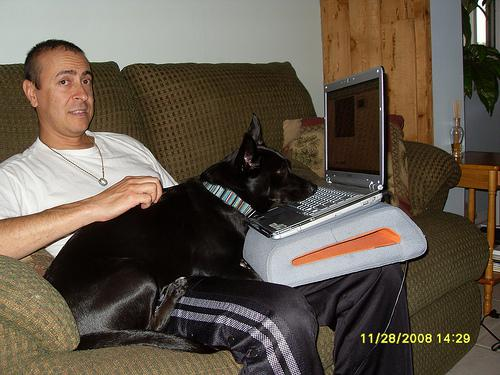Question: where is the computer?
Choices:
A. On his lap.
B. On the desk.
C. On the table.
D. On the chair.
Answer with the letter. Answer: A 